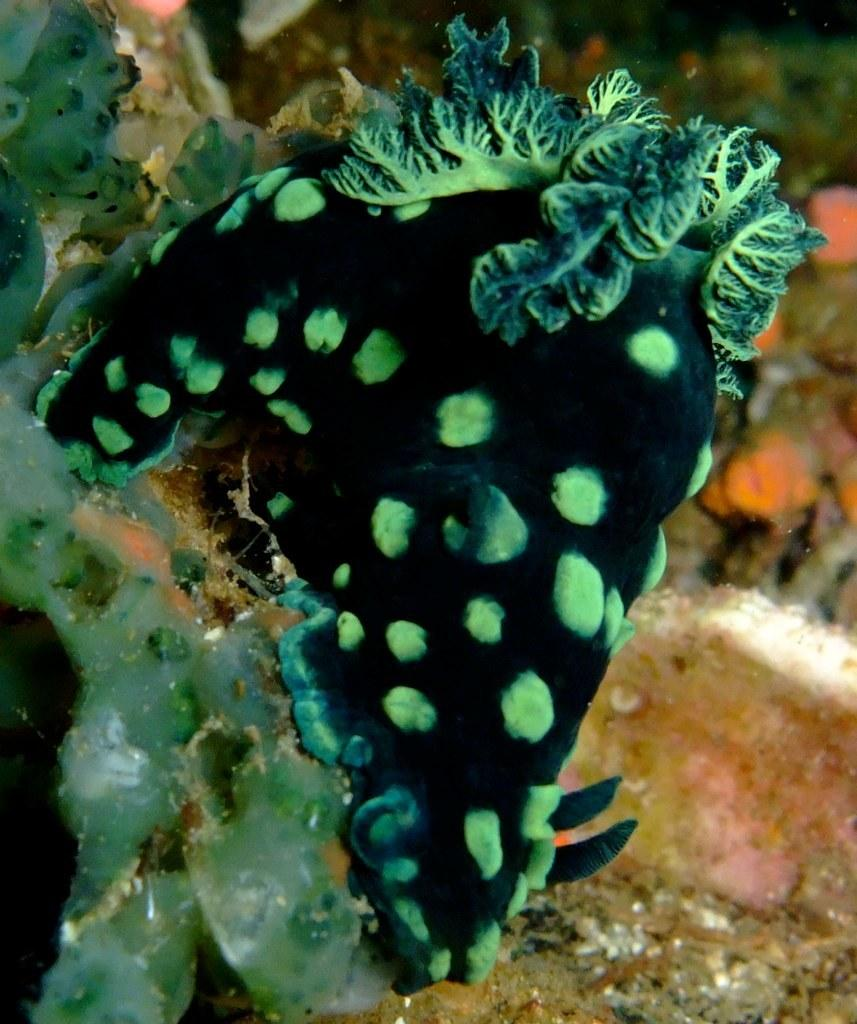What type of environment is depicted in the image? The image shows an underwater environment. What specific feature can be seen in this underwater environment? There are corals visible in the image. What type of bomb can be seen in the image? There is no bomb present in the image; it features underwater corals. Can you see any army personnel in the image? There is no army personnel present in the image; it features underwater corals. 